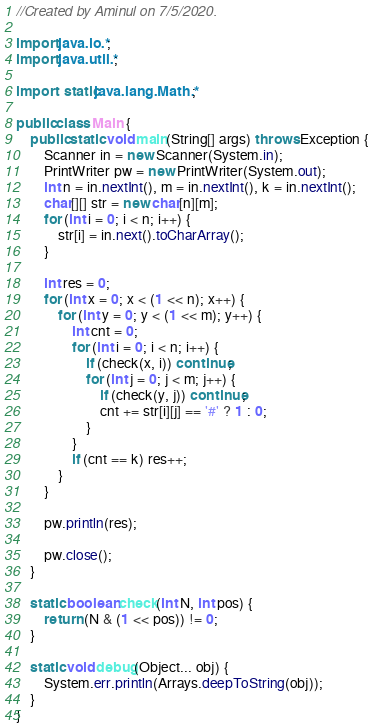<code> <loc_0><loc_0><loc_500><loc_500><_Java_>//Created by Aminul on 7/5/2020.

import java.io.*;
import java.util.*;

import static java.lang.Math.*;

public class Main {
    public static void main(String[] args) throws Exception {
        Scanner in = new Scanner(System.in);
        PrintWriter pw = new PrintWriter(System.out);
        int n = in.nextInt(), m = in.nextInt(), k = in.nextInt();
        char[][] str = new char[n][m];
        for (int i = 0; i < n; i++) {
            str[i] = in.next().toCharArray();
        }

        int res = 0;
        for (int x = 0; x < (1 << n); x++) {
            for (int y = 0; y < (1 << m); y++) {
                int cnt = 0;
                for (int i = 0; i < n; i++) {
                    if (check(x, i)) continue;
                    for (int j = 0; j < m; j++) {
                        if (check(y, j)) continue;
                        cnt += str[i][j] == '#' ? 1 : 0;
                    }
                }
                if (cnt == k) res++;
            }
        }

        pw.println(res);

        pw.close();
    }

    static boolean check(int N, int pos) {
        return (N & (1 << pos)) != 0;
    }

    static void debug(Object... obj) {
        System.err.println(Arrays.deepToString(obj));
    }
}</code> 